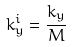<formula> <loc_0><loc_0><loc_500><loc_500>k _ { y } ^ { i } = \frac { k _ { y } } { M }</formula> 